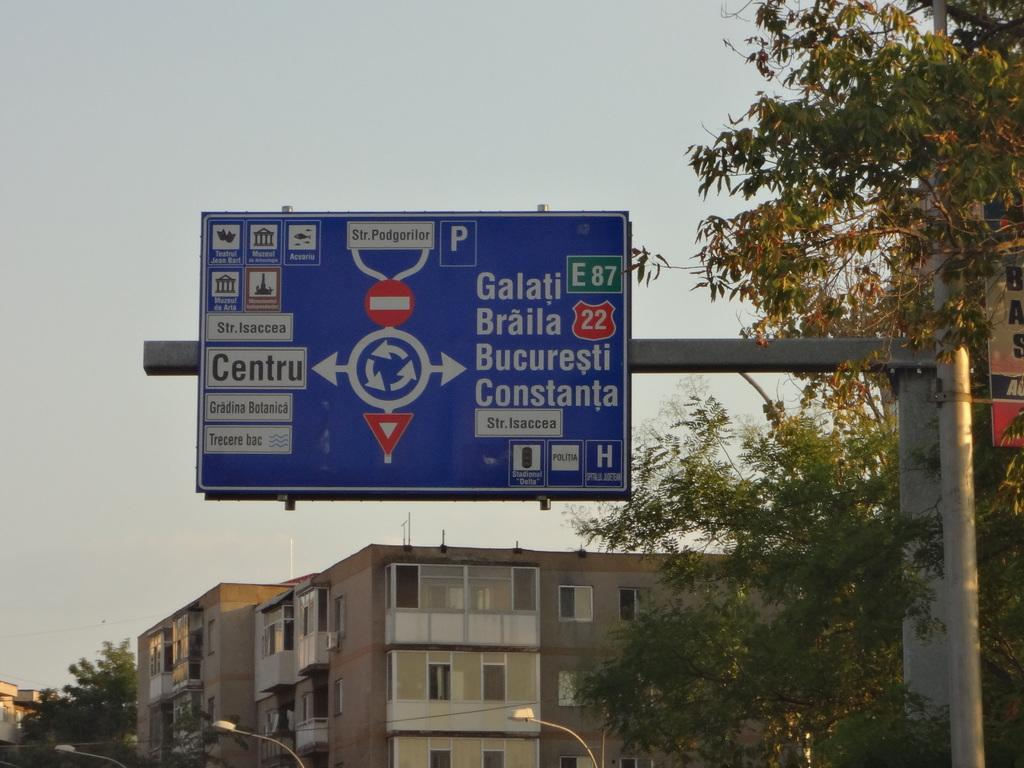Provide a one-sentence caption for the provided image. A blue street sign that is written in a foreign language and says Galati E87 on it. 